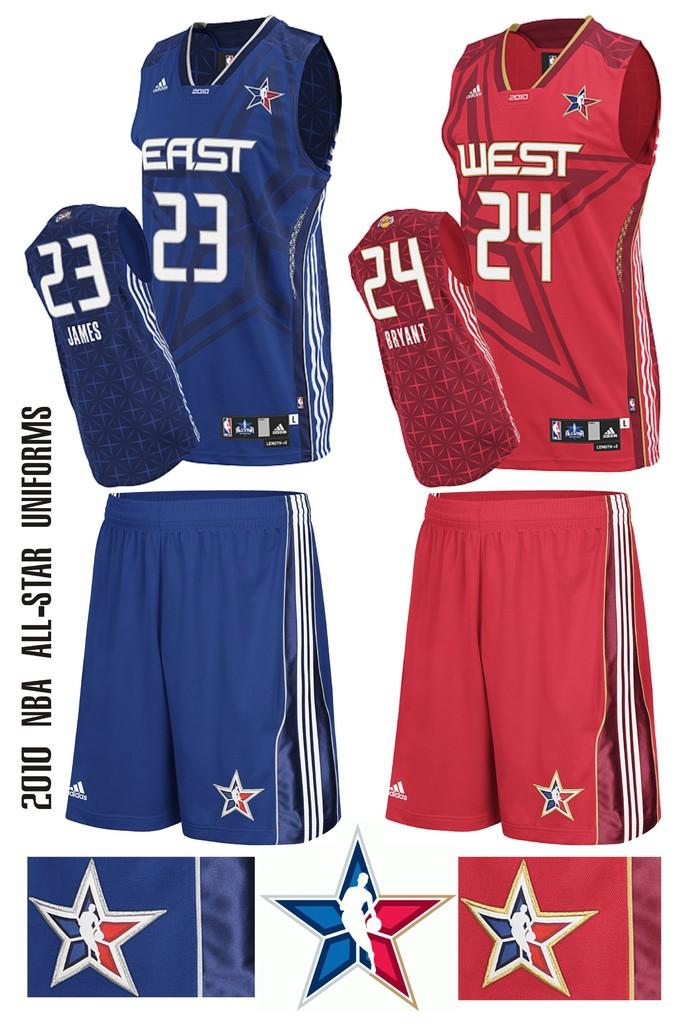<image>
Create a compact narrative representing the image presented. Jerseys have team names east and west on them. 